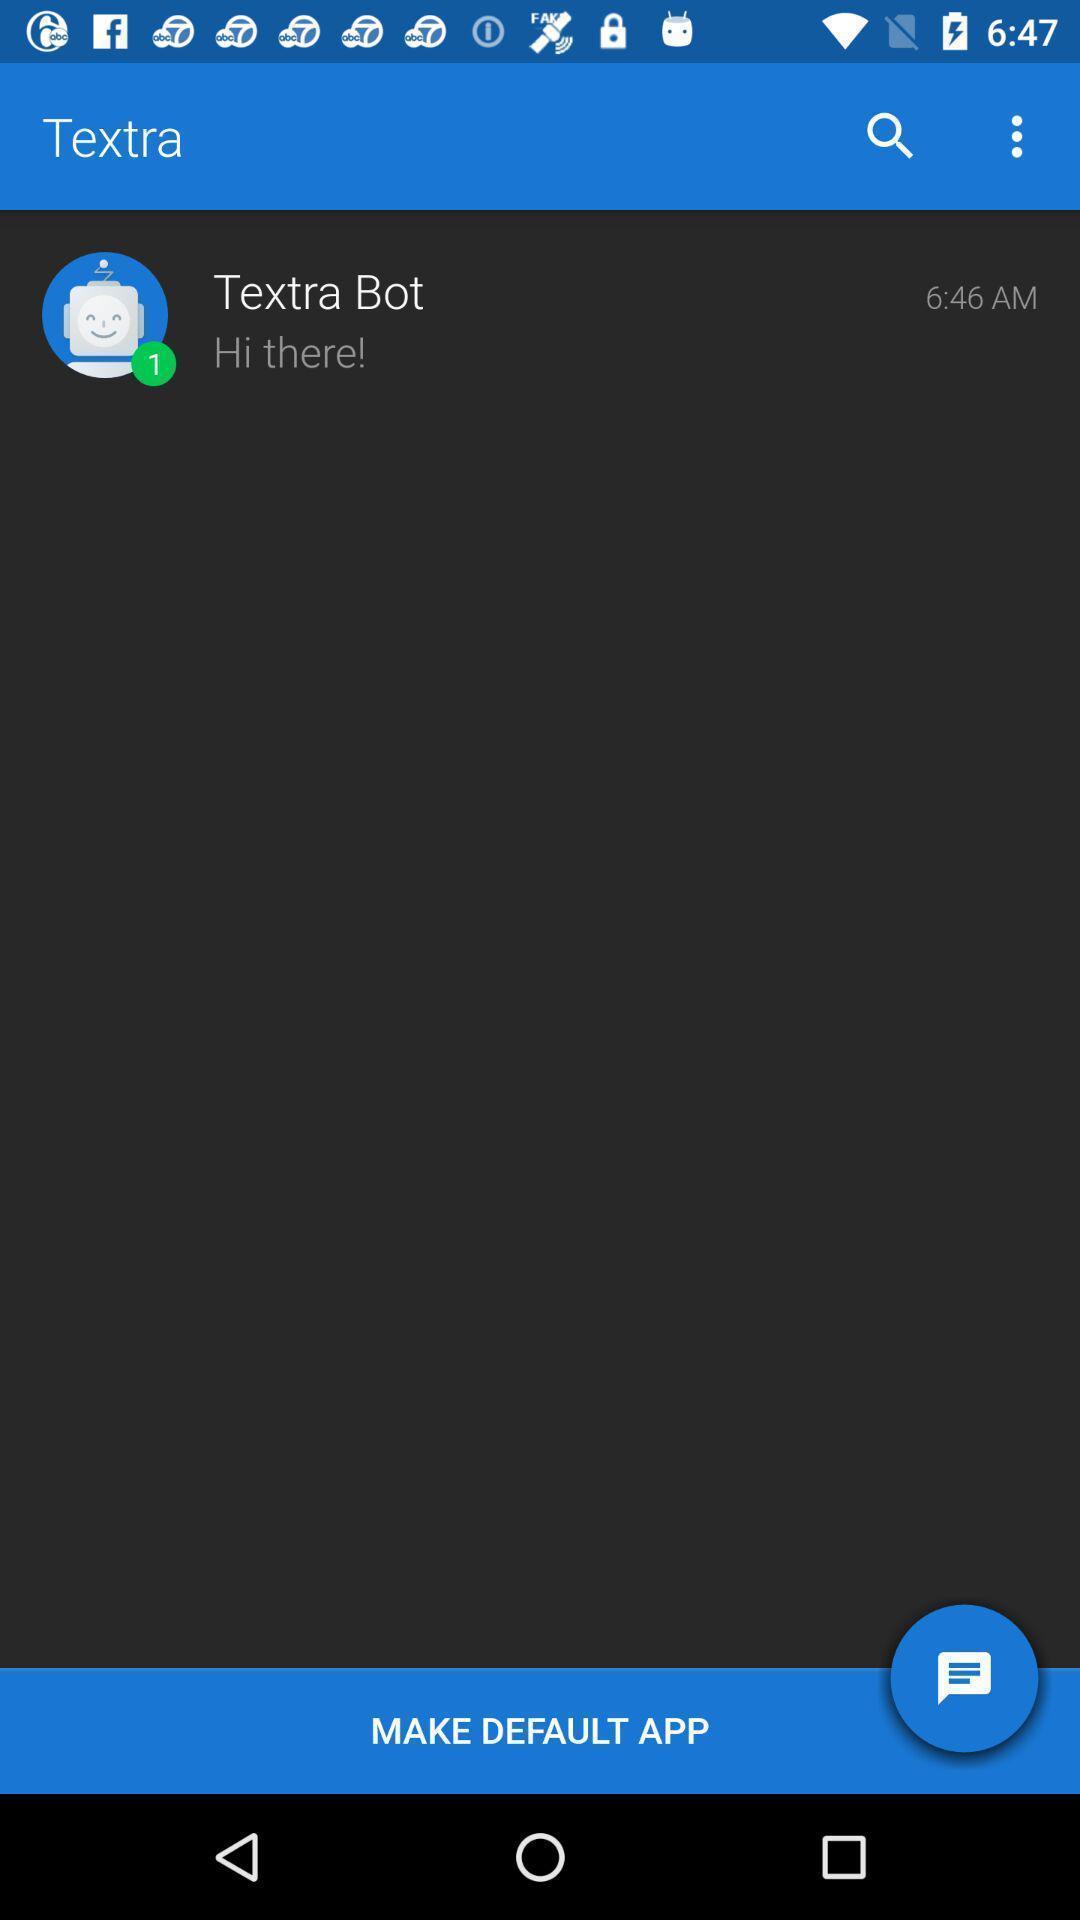Provide a textual representation of this image. Page showing the chat box of a social app. 